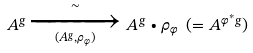Convert formula to latex. <formula><loc_0><loc_0><loc_500><loc_500>A ^ { g } \xrightarrow [ ( A ^ { g } , \rho _ { \varphi } ) ] { \sim } A ^ { g } \bullet \rho _ { \varphi } \ ( = A ^ { \varphi ^ { * } g } )</formula> 